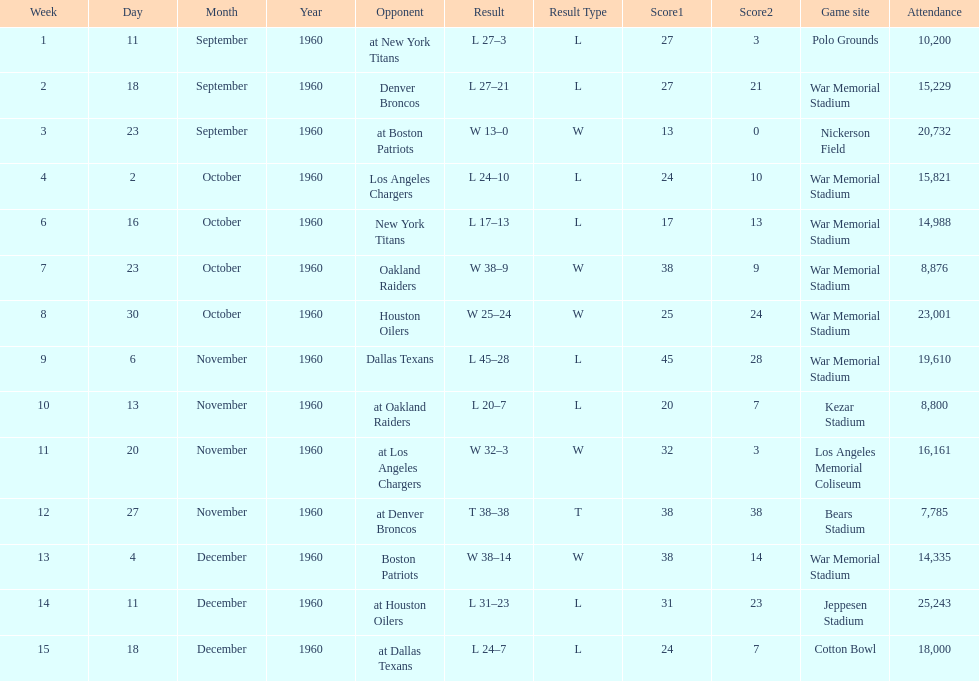What date was the first game at war memorial stadium? September 18, 1960. 